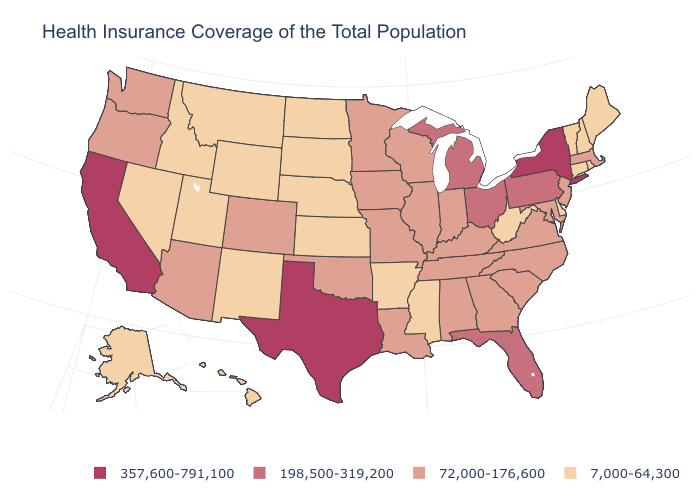Is the legend a continuous bar?
Write a very short answer. No. What is the value of Massachusetts?
Answer briefly. 72,000-176,600. What is the lowest value in the South?
Quick response, please. 7,000-64,300. Name the states that have a value in the range 72,000-176,600?
Give a very brief answer. Alabama, Arizona, Colorado, Georgia, Illinois, Indiana, Iowa, Kentucky, Louisiana, Maryland, Massachusetts, Minnesota, Missouri, New Jersey, North Carolina, Oklahoma, Oregon, South Carolina, Tennessee, Virginia, Washington, Wisconsin. Among the states that border New York , does New Jersey have the lowest value?
Write a very short answer. No. What is the value of Arizona?
Short answer required. 72,000-176,600. What is the value of Utah?
Write a very short answer. 7,000-64,300. Name the states that have a value in the range 198,500-319,200?
Be succinct. Florida, Michigan, Ohio, Pennsylvania. What is the highest value in the West ?
Be succinct. 357,600-791,100. What is the value of Arkansas?
Give a very brief answer. 7,000-64,300. What is the lowest value in the West?
Answer briefly. 7,000-64,300. What is the lowest value in the West?
Be succinct. 7,000-64,300. Does Kansas have the lowest value in the MidWest?
Short answer required. Yes. Does the map have missing data?
Concise answer only. No. 